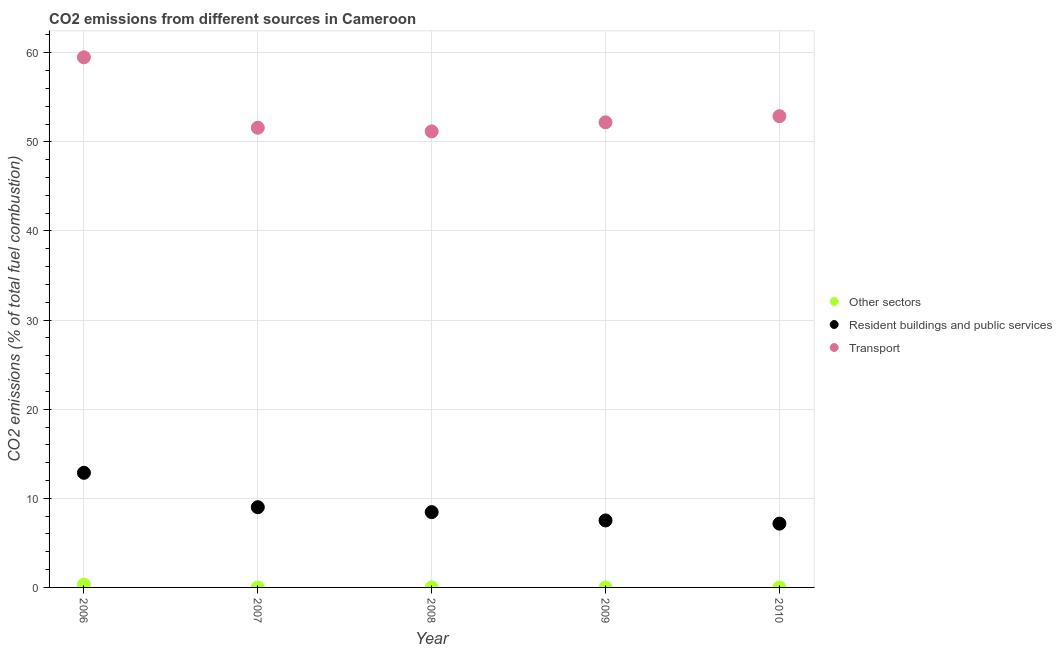What is the percentage of co2 emissions from transport in 2008?
Provide a succinct answer. 51.17. Across all years, what is the maximum percentage of co2 emissions from other sectors?
Offer a very short reply. 0.32. Across all years, what is the minimum percentage of co2 emissions from resident buildings and public services?
Provide a short and direct response. 7.16. What is the total percentage of co2 emissions from resident buildings and public services in the graph?
Your answer should be very brief. 44.99. What is the difference between the percentage of co2 emissions from other sectors in 2008 and that in 2010?
Offer a very short reply. 3.116832051125499e-17. What is the difference between the percentage of co2 emissions from resident buildings and public services in 2007 and the percentage of co2 emissions from transport in 2008?
Your response must be concise. -42.17. What is the average percentage of co2 emissions from transport per year?
Your answer should be compact. 53.46. In the year 2009, what is the difference between the percentage of co2 emissions from other sectors and percentage of co2 emissions from resident buildings and public services?
Offer a very short reply. -7.52. In how many years, is the percentage of co2 emissions from transport greater than 44 %?
Give a very brief answer. 5. What is the ratio of the percentage of co2 emissions from transport in 2006 to that in 2010?
Provide a succinct answer. 1.12. What is the difference between the highest and the second highest percentage of co2 emissions from resident buildings and public services?
Offer a terse response. 3.86. What is the difference between the highest and the lowest percentage of co2 emissions from transport?
Make the answer very short. 8.31. Is the sum of the percentage of co2 emissions from resident buildings and public services in 2006 and 2009 greater than the maximum percentage of co2 emissions from transport across all years?
Ensure brevity in your answer.  No. Is it the case that in every year, the sum of the percentage of co2 emissions from other sectors and percentage of co2 emissions from resident buildings and public services is greater than the percentage of co2 emissions from transport?
Provide a short and direct response. No. Does the percentage of co2 emissions from resident buildings and public services monotonically increase over the years?
Provide a succinct answer. No. Is the percentage of co2 emissions from other sectors strictly less than the percentage of co2 emissions from resident buildings and public services over the years?
Your answer should be compact. Yes. How many dotlines are there?
Your answer should be compact. 3. What is the difference between two consecutive major ticks on the Y-axis?
Your answer should be compact. 10. Are the values on the major ticks of Y-axis written in scientific E-notation?
Provide a succinct answer. No. Does the graph contain any zero values?
Ensure brevity in your answer.  No. Where does the legend appear in the graph?
Your answer should be very brief. Center right. How many legend labels are there?
Provide a succinct answer. 3. What is the title of the graph?
Give a very brief answer. CO2 emissions from different sources in Cameroon. What is the label or title of the X-axis?
Your response must be concise. Year. What is the label or title of the Y-axis?
Your answer should be very brief. CO2 emissions (% of total fuel combustion). What is the CO2 emissions (% of total fuel combustion) in Other sectors in 2006?
Give a very brief answer. 0.32. What is the CO2 emissions (% of total fuel combustion) in Resident buildings and public services in 2006?
Keep it short and to the point. 12.86. What is the CO2 emissions (% of total fuel combustion) of Transport in 2006?
Offer a terse response. 59.49. What is the CO2 emissions (% of total fuel combustion) in Other sectors in 2007?
Your answer should be compact. 2.1103691921859e-16. What is the CO2 emissions (% of total fuel combustion) in Resident buildings and public services in 2007?
Offer a very short reply. 9. What is the CO2 emissions (% of total fuel combustion) in Transport in 2007?
Give a very brief answer. 51.58. What is the CO2 emissions (% of total fuel combustion) of Other sectors in 2008?
Give a very brief answer. 2.03606041781315e-16. What is the CO2 emissions (% of total fuel combustion) in Resident buildings and public services in 2008?
Your answer should be very brief. 8.45. What is the CO2 emissions (% of total fuel combustion) in Transport in 2008?
Make the answer very short. 51.17. What is the CO2 emissions (% of total fuel combustion) in Other sectors in 2009?
Provide a short and direct response. 1.810776070957e-16. What is the CO2 emissions (% of total fuel combustion) in Resident buildings and public services in 2009?
Offer a very short reply. 7.52. What is the CO2 emissions (% of total fuel combustion) in Transport in 2009?
Your response must be concise. 52.19. What is the CO2 emissions (% of total fuel combustion) of Other sectors in 2010?
Your response must be concise. 1.7243772127006e-16. What is the CO2 emissions (% of total fuel combustion) of Resident buildings and public services in 2010?
Your response must be concise. 7.16. What is the CO2 emissions (% of total fuel combustion) in Transport in 2010?
Provide a short and direct response. 52.88. Across all years, what is the maximum CO2 emissions (% of total fuel combustion) in Other sectors?
Make the answer very short. 0.32. Across all years, what is the maximum CO2 emissions (% of total fuel combustion) of Resident buildings and public services?
Make the answer very short. 12.86. Across all years, what is the maximum CO2 emissions (% of total fuel combustion) of Transport?
Keep it short and to the point. 59.49. Across all years, what is the minimum CO2 emissions (% of total fuel combustion) of Other sectors?
Offer a terse response. 1.7243772127006e-16. Across all years, what is the minimum CO2 emissions (% of total fuel combustion) in Resident buildings and public services?
Your answer should be very brief. 7.16. Across all years, what is the minimum CO2 emissions (% of total fuel combustion) of Transport?
Offer a terse response. 51.17. What is the total CO2 emissions (% of total fuel combustion) of Other sectors in the graph?
Provide a succinct answer. 0.32. What is the total CO2 emissions (% of total fuel combustion) in Resident buildings and public services in the graph?
Offer a very short reply. 44.99. What is the total CO2 emissions (% of total fuel combustion) of Transport in the graph?
Ensure brevity in your answer.  267.32. What is the difference between the CO2 emissions (% of total fuel combustion) in Other sectors in 2006 and that in 2007?
Your answer should be very brief. 0.32. What is the difference between the CO2 emissions (% of total fuel combustion) of Resident buildings and public services in 2006 and that in 2007?
Your response must be concise. 3.86. What is the difference between the CO2 emissions (% of total fuel combustion) of Transport in 2006 and that in 2007?
Your answer should be compact. 7.9. What is the difference between the CO2 emissions (% of total fuel combustion) of Other sectors in 2006 and that in 2008?
Ensure brevity in your answer.  0.32. What is the difference between the CO2 emissions (% of total fuel combustion) of Resident buildings and public services in 2006 and that in 2008?
Offer a very short reply. 4.41. What is the difference between the CO2 emissions (% of total fuel combustion) in Transport in 2006 and that in 2008?
Offer a very short reply. 8.31. What is the difference between the CO2 emissions (% of total fuel combustion) in Other sectors in 2006 and that in 2009?
Offer a very short reply. 0.32. What is the difference between the CO2 emissions (% of total fuel combustion) in Resident buildings and public services in 2006 and that in 2009?
Make the answer very short. 5.35. What is the difference between the CO2 emissions (% of total fuel combustion) of Transport in 2006 and that in 2009?
Give a very brief answer. 7.29. What is the difference between the CO2 emissions (% of total fuel combustion) of Other sectors in 2006 and that in 2010?
Keep it short and to the point. 0.32. What is the difference between the CO2 emissions (% of total fuel combustion) in Resident buildings and public services in 2006 and that in 2010?
Keep it short and to the point. 5.7. What is the difference between the CO2 emissions (% of total fuel combustion) of Transport in 2006 and that in 2010?
Provide a succinct answer. 6.6. What is the difference between the CO2 emissions (% of total fuel combustion) in Other sectors in 2007 and that in 2008?
Provide a short and direct response. 0. What is the difference between the CO2 emissions (% of total fuel combustion) in Resident buildings and public services in 2007 and that in 2008?
Ensure brevity in your answer.  0.55. What is the difference between the CO2 emissions (% of total fuel combustion) of Transport in 2007 and that in 2008?
Offer a very short reply. 0.41. What is the difference between the CO2 emissions (% of total fuel combustion) in Resident buildings and public services in 2007 and that in 2009?
Keep it short and to the point. 1.49. What is the difference between the CO2 emissions (% of total fuel combustion) of Transport in 2007 and that in 2009?
Your response must be concise. -0.61. What is the difference between the CO2 emissions (% of total fuel combustion) of Resident buildings and public services in 2007 and that in 2010?
Your answer should be compact. 1.85. What is the difference between the CO2 emissions (% of total fuel combustion) in Transport in 2007 and that in 2010?
Ensure brevity in your answer.  -1.3. What is the difference between the CO2 emissions (% of total fuel combustion) in Resident buildings and public services in 2008 and that in 2009?
Offer a very short reply. 0.94. What is the difference between the CO2 emissions (% of total fuel combustion) in Transport in 2008 and that in 2009?
Your answer should be very brief. -1.02. What is the difference between the CO2 emissions (% of total fuel combustion) of Other sectors in 2008 and that in 2010?
Offer a terse response. 0. What is the difference between the CO2 emissions (% of total fuel combustion) of Resident buildings and public services in 2008 and that in 2010?
Provide a short and direct response. 1.29. What is the difference between the CO2 emissions (% of total fuel combustion) in Transport in 2008 and that in 2010?
Your answer should be compact. -1.71. What is the difference between the CO2 emissions (% of total fuel combustion) of Other sectors in 2009 and that in 2010?
Your answer should be compact. 0. What is the difference between the CO2 emissions (% of total fuel combustion) of Resident buildings and public services in 2009 and that in 2010?
Give a very brief answer. 0.36. What is the difference between the CO2 emissions (% of total fuel combustion) in Transport in 2009 and that in 2010?
Ensure brevity in your answer.  -0.69. What is the difference between the CO2 emissions (% of total fuel combustion) of Other sectors in 2006 and the CO2 emissions (% of total fuel combustion) of Resident buildings and public services in 2007?
Your answer should be compact. -8.68. What is the difference between the CO2 emissions (% of total fuel combustion) in Other sectors in 2006 and the CO2 emissions (% of total fuel combustion) in Transport in 2007?
Your answer should be very brief. -51.26. What is the difference between the CO2 emissions (% of total fuel combustion) in Resident buildings and public services in 2006 and the CO2 emissions (% of total fuel combustion) in Transport in 2007?
Provide a short and direct response. -38.72. What is the difference between the CO2 emissions (% of total fuel combustion) in Other sectors in 2006 and the CO2 emissions (% of total fuel combustion) in Resident buildings and public services in 2008?
Provide a short and direct response. -8.13. What is the difference between the CO2 emissions (% of total fuel combustion) in Other sectors in 2006 and the CO2 emissions (% of total fuel combustion) in Transport in 2008?
Your answer should be very brief. -50.85. What is the difference between the CO2 emissions (% of total fuel combustion) of Resident buildings and public services in 2006 and the CO2 emissions (% of total fuel combustion) of Transport in 2008?
Give a very brief answer. -38.31. What is the difference between the CO2 emissions (% of total fuel combustion) in Other sectors in 2006 and the CO2 emissions (% of total fuel combustion) in Resident buildings and public services in 2009?
Offer a very short reply. -7.19. What is the difference between the CO2 emissions (% of total fuel combustion) of Other sectors in 2006 and the CO2 emissions (% of total fuel combustion) of Transport in 2009?
Offer a very short reply. -51.87. What is the difference between the CO2 emissions (% of total fuel combustion) of Resident buildings and public services in 2006 and the CO2 emissions (% of total fuel combustion) of Transport in 2009?
Your answer should be compact. -39.33. What is the difference between the CO2 emissions (% of total fuel combustion) of Other sectors in 2006 and the CO2 emissions (% of total fuel combustion) of Resident buildings and public services in 2010?
Offer a very short reply. -6.84. What is the difference between the CO2 emissions (% of total fuel combustion) in Other sectors in 2006 and the CO2 emissions (% of total fuel combustion) in Transport in 2010?
Give a very brief answer. -52.56. What is the difference between the CO2 emissions (% of total fuel combustion) in Resident buildings and public services in 2006 and the CO2 emissions (% of total fuel combustion) in Transport in 2010?
Your answer should be very brief. -40.02. What is the difference between the CO2 emissions (% of total fuel combustion) of Other sectors in 2007 and the CO2 emissions (% of total fuel combustion) of Resident buildings and public services in 2008?
Provide a short and direct response. -8.45. What is the difference between the CO2 emissions (% of total fuel combustion) of Other sectors in 2007 and the CO2 emissions (% of total fuel combustion) of Transport in 2008?
Give a very brief answer. -51.17. What is the difference between the CO2 emissions (% of total fuel combustion) of Resident buildings and public services in 2007 and the CO2 emissions (% of total fuel combustion) of Transport in 2008?
Your response must be concise. -42.17. What is the difference between the CO2 emissions (% of total fuel combustion) of Other sectors in 2007 and the CO2 emissions (% of total fuel combustion) of Resident buildings and public services in 2009?
Provide a succinct answer. -7.52. What is the difference between the CO2 emissions (% of total fuel combustion) of Other sectors in 2007 and the CO2 emissions (% of total fuel combustion) of Transport in 2009?
Your answer should be very brief. -52.19. What is the difference between the CO2 emissions (% of total fuel combustion) of Resident buildings and public services in 2007 and the CO2 emissions (% of total fuel combustion) of Transport in 2009?
Provide a succinct answer. -43.19. What is the difference between the CO2 emissions (% of total fuel combustion) of Other sectors in 2007 and the CO2 emissions (% of total fuel combustion) of Resident buildings and public services in 2010?
Offer a terse response. -7.16. What is the difference between the CO2 emissions (% of total fuel combustion) of Other sectors in 2007 and the CO2 emissions (% of total fuel combustion) of Transport in 2010?
Offer a very short reply. -52.88. What is the difference between the CO2 emissions (% of total fuel combustion) of Resident buildings and public services in 2007 and the CO2 emissions (% of total fuel combustion) of Transport in 2010?
Ensure brevity in your answer.  -43.88. What is the difference between the CO2 emissions (% of total fuel combustion) of Other sectors in 2008 and the CO2 emissions (% of total fuel combustion) of Resident buildings and public services in 2009?
Make the answer very short. -7.52. What is the difference between the CO2 emissions (% of total fuel combustion) of Other sectors in 2008 and the CO2 emissions (% of total fuel combustion) of Transport in 2009?
Your response must be concise. -52.19. What is the difference between the CO2 emissions (% of total fuel combustion) of Resident buildings and public services in 2008 and the CO2 emissions (% of total fuel combustion) of Transport in 2009?
Your answer should be compact. -43.74. What is the difference between the CO2 emissions (% of total fuel combustion) of Other sectors in 2008 and the CO2 emissions (% of total fuel combustion) of Resident buildings and public services in 2010?
Your answer should be compact. -7.16. What is the difference between the CO2 emissions (% of total fuel combustion) in Other sectors in 2008 and the CO2 emissions (% of total fuel combustion) in Transport in 2010?
Provide a succinct answer. -52.88. What is the difference between the CO2 emissions (% of total fuel combustion) of Resident buildings and public services in 2008 and the CO2 emissions (% of total fuel combustion) of Transport in 2010?
Your answer should be compact. -44.43. What is the difference between the CO2 emissions (% of total fuel combustion) of Other sectors in 2009 and the CO2 emissions (% of total fuel combustion) of Resident buildings and public services in 2010?
Offer a very short reply. -7.16. What is the difference between the CO2 emissions (% of total fuel combustion) in Other sectors in 2009 and the CO2 emissions (% of total fuel combustion) in Transport in 2010?
Keep it short and to the point. -52.88. What is the difference between the CO2 emissions (% of total fuel combustion) of Resident buildings and public services in 2009 and the CO2 emissions (% of total fuel combustion) of Transport in 2010?
Make the answer very short. -45.37. What is the average CO2 emissions (% of total fuel combustion) of Other sectors per year?
Make the answer very short. 0.06. What is the average CO2 emissions (% of total fuel combustion) in Resident buildings and public services per year?
Offer a very short reply. 9. What is the average CO2 emissions (% of total fuel combustion) of Transport per year?
Ensure brevity in your answer.  53.46. In the year 2006, what is the difference between the CO2 emissions (% of total fuel combustion) of Other sectors and CO2 emissions (% of total fuel combustion) of Resident buildings and public services?
Provide a succinct answer. -12.54. In the year 2006, what is the difference between the CO2 emissions (% of total fuel combustion) of Other sectors and CO2 emissions (% of total fuel combustion) of Transport?
Your answer should be compact. -59.16. In the year 2006, what is the difference between the CO2 emissions (% of total fuel combustion) in Resident buildings and public services and CO2 emissions (% of total fuel combustion) in Transport?
Your answer should be very brief. -46.62. In the year 2007, what is the difference between the CO2 emissions (% of total fuel combustion) in Other sectors and CO2 emissions (% of total fuel combustion) in Resident buildings and public services?
Give a very brief answer. -9. In the year 2007, what is the difference between the CO2 emissions (% of total fuel combustion) of Other sectors and CO2 emissions (% of total fuel combustion) of Transport?
Make the answer very short. -51.58. In the year 2007, what is the difference between the CO2 emissions (% of total fuel combustion) of Resident buildings and public services and CO2 emissions (% of total fuel combustion) of Transport?
Your answer should be very brief. -42.58. In the year 2008, what is the difference between the CO2 emissions (% of total fuel combustion) in Other sectors and CO2 emissions (% of total fuel combustion) in Resident buildings and public services?
Ensure brevity in your answer.  -8.45. In the year 2008, what is the difference between the CO2 emissions (% of total fuel combustion) in Other sectors and CO2 emissions (% of total fuel combustion) in Transport?
Provide a short and direct response. -51.17. In the year 2008, what is the difference between the CO2 emissions (% of total fuel combustion) in Resident buildings and public services and CO2 emissions (% of total fuel combustion) in Transport?
Offer a terse response. -42.72. In the year 2009, what is the difference between the CO2 emissions (% of total fuel combustion) in Other sectors and CO2 emissions (% of total fuel combustion) in Resident buildings and public services?
Give a very brief answer. -7.52. In the year 2009, what is the difference between the CO2 emissions (% of total fuel combustion) in Other sectors and CO2 emissions (% of total fuel combustion) in Transport?
Offer a very short reply. -52.19. In the year 2009, what is the difference between the CO2 emissions (% of total fuel combustion) in Resident buildings and public services and CO2 emissions (% of total fuel combustion) in Transport?
Offer a very short reply. -44.68. In the year 2010, what is the difference between the CO2 emissions (% of total fuel combustion) of Other sectors and CO2 emissions (% of total fuel combustion) of Resident buildings and public services?
Offer a very short reply. -7.16. In the year 2010, what is the difference between the CO2 emissions (% of total fuel combustion) of Other sectors and CO2 emissions (% of total fuel combustion) of Transport?
Offer a terse response. -52.88. In the year 2010, what is the difference between the CO2 emissions (% of total fuel combustion) of Resident buildings and public services and CO2 emissions (% of total fuel combustion) of Transport?
Provide a succinct answer. -45.73. What is the ratio of the CO2 emissions (% of total fuel combustion) of Other sectors in 2006 to that in 2007?
Ensure brevity in your answer.  1.52e+15. What is the ratio of the CO2 emissions (% of total fuel combustion) of Resident buildings and public services in 2006 to that in 2007?
Give a very brief answer. 1.43. What is the ratio of the CO2 emissions (% of total fuel combustion) of Transport in 2006 to that in 2007?
Keep it short and to the point. 1.15. What is the ratio of the CO2 emissions (% of total fuel combustion) in Other sectors in 2006 to that in 2008?
Make the answer very short. 1.58e+15. What is the ratio of the CO2 emissions (% of total fuel combustion) in Resident buildings and public services in 2006 to that in 2008?
Give a very brief answer. 1.52. What is the ratio of the CO2 emissions (% of total fuel combustion) of Transport in 2006 to that in 2008?
Provide a succinct answer. 1.16. What is the ratio of the CO2 emissions (% of total fuel combustion) in Other sectors in 2006 to that in 2009?
Make the answer very short. 1.78e+15. What is the ratio of the CO2 emissions (% of total fuel combustion) of Resident buildings and public services in 2006 to that in 2009?
Offer a very short reply. 1.71. What is the ratio of the CO2 emissions (% of total fuel combustion) in Transport in 2006 to that in 2009?
Offer a terse response. 1.14. What is the ratio of the CO2 emissions (% of total fuel combustion) in Other sectors in 2006 to that in 2010?
Your response must be concise. 1.86e+15. What is the ratio of the CO2 emissions (% of total fuel combustion) of Resident buildings and public services in 2006 to that in 2010?
Offer a terse response. 1.8. What is the ratio of the CO2 emissions (% of total fuel combustion) of Transport in 2006 to that in 2010?
Provide a short and direct response. 1.12. What is the ratio of the CO2 emissions (% of total fuel combustion) in Other sectors in 2007 to that in 2008?
Offer a terse response. 1.04. What is the ratio of the CO2 emissions (% of total fuel combustion) in Resident buildings and public services in 2007 to that in 2008?
Your answer should be very brief. 1.07. What is the ratio of the CO2 emissions (% of total fuel combustion) in Other sectors in 2007 to that in 2009?
Ensure brevity in your answer.  1.17. What is the ratio of the CO2 emissions (% of total fuel combustion) in Resident buildings and public services in 2007 to that in 2009?
Provide a succinct answer. 1.2. What is the ratio of the CO2 emissions (% of total fuel combustion) in Transport in 2007 to that in 2009?
Give a very brief answer. 0.99. What is the ratio of the CO2 emissions (% of total fuel combustion) in Other sectors in 2007 to that in 2010?
Give a very brief answer. 1.22. What is the ratio of the CO2 emissions (% of total fuel combustion) of Resident buildings and public services in 2007 to that in 2010?
Your answer should be very brief. 1.26. What is the ratio of the CO2 emissions (% of total fuel combustion) in Transport in 2007 to that in 2010?
Provide a succinct answer. 0.98. What is the ratio of the CO2 emissions (% of total fuel combustion) of Other sectors in 2008 to that in 2009?
Offer a very short reply. 1.12. What is the ratio of the CO2 emissions (% of total fuel combustion) of Resident buildings and public services in 2008 to that in 2009?
Give a very brief answer. 1.12. What is the ratio of the CO2 emissions (% of total fuel combustion) in Transport in 2008 to that in 2009?
Make the answer very short. 0.98. What is the ratio of the CO2 emissions (% of total fuel combustion) of Other sectors in 2008 to that in 2010?
Your answer should be compact. 1.18. What is the ratio of the CO2 emissions (% of total fuel combustion) in Resident buildings and public services in 2008 to that in 2010?
Provide a short and direct response. 1.18. What is the ratio of the CO2 emissions (% of total fuel combustion) of Other sectors in 2009 to that in 2010?
Give a very brief answer. 1.05. What is the ratio of the CO2 emissions (% of total fuel combustion) in Resident buildings and public services in 2009 to that in 2010?
Your answer should be compact. 1.05. What is the ratio of the CO2 emissions (% of total fuel combustion) in Transport in 2009 to that in 2010?
Provide a succinct answer. 0.99. What is the difference between the highest and the second highest CO2 emissions (% of total fuel combustion) of Other sectors?
Your answer should be very brief. 0.32. What is the difference between the highest and the second highest CO2 emissions (% of total fuel combustion) of Resident buildings and public services?
Your answer should be compact. 3.86. What is the difference between the highest and the second highest CO2 emissions (% of total fuel combustion) of Transport?
Keep it short and to the point. 6.6. What is the difference between the highest and the lowest CO2 emissions (% of total fuel combustion) of Other sectors?
Give a very brief answer. 0.32. What is the difference between the highest and the lowest CO2 emissions (% of total fuel combustion) of Resident buildings and public services?
Ensure brevity in your answer.  5.7. What is the difference between the highest and the lowest CO2 emissions (% of total fuel combustion) in Transport?
Keep it short and to the point. 8.31. 